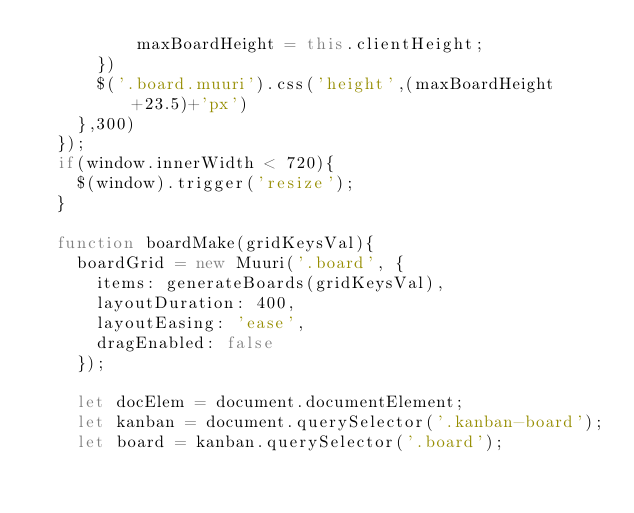<code> <loc_0><loc_0><loc_500><loc_500><_JavaScript_>          maxBoardHeight = this.clientHeight;
      })
      $('.board.muuri').css('height',(maxBoardHeight+23.5)+'px')
    },300)
  });
  if(window.innerWidth < 720){
    $(window).trigger('resize');
  }

  function boardMake(gridKeysVal){
    boardGrid = new Muuri('.board', {
      items: generateBoards(gridKeysVal),
      layoutDuration: 400,
      layoutEasing: 'ease',
      dragEnabled: false
    });

    let docElem = document.documentElement;
    let kanban = document.querySelector('.kanban-board');
    let board = kanban.querySelector('.board');</code> 